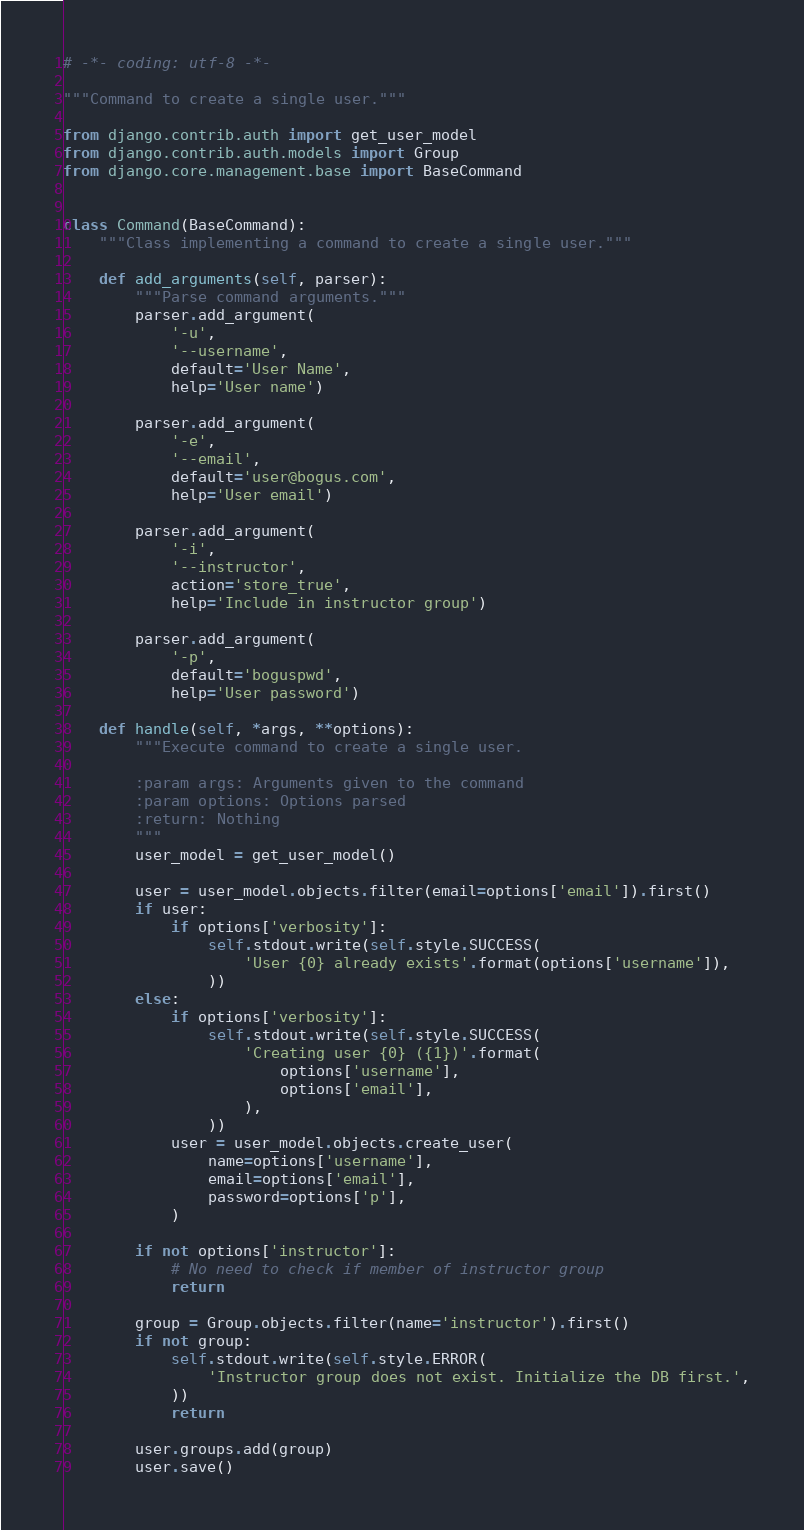Convert code to text. <code><loc_0><loc_0><loc_500><loc_500><_Python_># -*- coding: utf-8 -*-

"""Command to create a single user."""

from django.contrib.auth import get_user_model
from django.contrib.auth.models import Group
from django.core.management.base import BaseCommand


class Command(BaseCommand):
    """Class implementing a command to create a single user."""

    def add_arguments(self, parser):
        """Parse command arguments."""
        parser.add_argument(
            '-u',
            '--username',
            default='User Name',
            help='User name')

        parser.add_argument(
            '-e',
            '--email',
            default='user@bogus.com',
            help='User email')

        parser.add_argument(
            '-i',
            '--instructor',
            action='store_true',
            help='Include in instructor group')

        parser.add_argument(
            '-p',
            default='boguspwd',
            help='User password')

    def handle(self, *args, **options):
        """Execute command to create a single user.

        :param args: Arguments given to the command
        :param options: Options parsed
        :return: Nothing
        """
        user_model = get_user_model()

        user = user_model.objects.filter(email=options['email']).first()
        if user:
            if options['verbosity']:
                self.stdout.write(self.style.SUCCESS(
                    'User {0} already exists'.format(options['username']),
                ))
        else:
            if options['verbosity']:
                self.stdout.write(self.style.SUCCESS(
                    'Creating user {0} ({1})'.format(
                        options['username'],
                        options['email'],
                    ),
                ))
            user = user_model.objects.create_user(
                name=options['username'],
                email=options['email'],
                password=options['p'],
            )

        if not options['instructor']:
            # No need to check if member of instructor group
            return

        group = Group.objects.filter(name='instructor').first()
        if not group:
            self.stdout.write(self.style.ERROR(
                'Instructor group does not exist. Initialize the DB first.',
            ))
            return

        user.groups.add(group)
        user.save()
</code> 